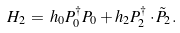<formula> <loc_0><loc_0><loc_500><loc_500>H _ { 2 } \, = \, h _ { 0 } P ^ { \dagger } _ { 0 } P _ { 0 } + h _ { 2 } P ^ { \dagger } _ { 2 } \cdot \tilde { P } _ { 2 } .</formula> 